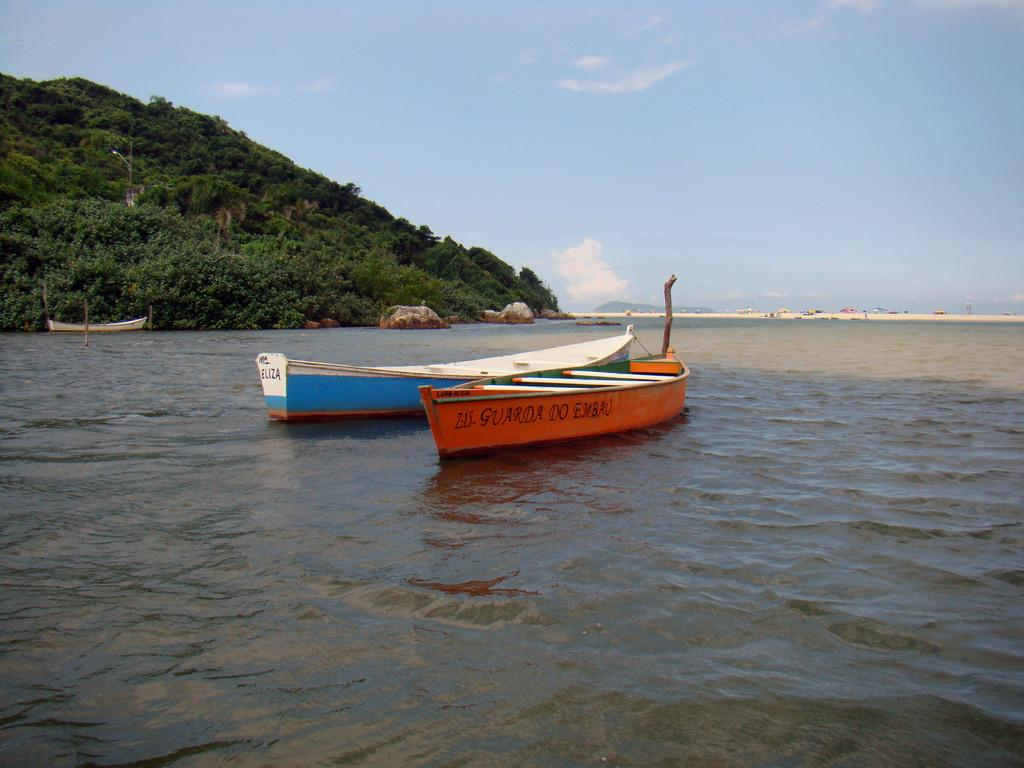What is in the water in the image? There are boats in the water in the image. What geographical feature can be seen in the image? There is a mountain in the image. How are the trees distributed on the mountain? The mountain is covered with trees. Where is the mountain located in the image? The mountain is in the left corner of the image. What is the color of the sky in the image? The sky is blue in color. What type of crack is visible on the mountain in the image? There is no crack visible on the mountain in the image. Where is the faucet located in the image? There is no faucet present in the image. 